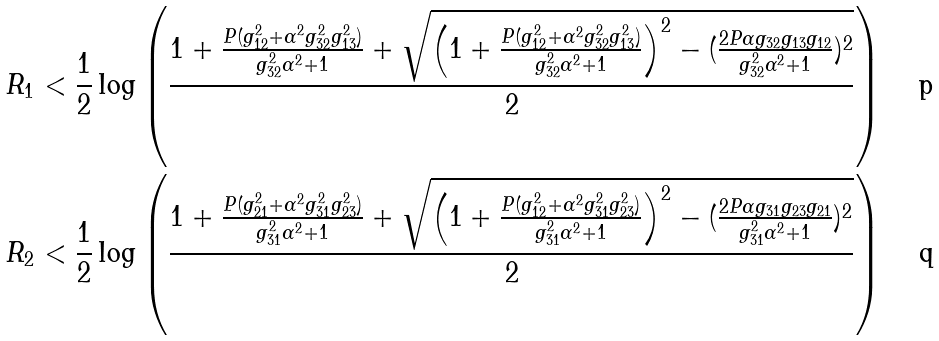<formula> <loc_0><loc_0><loc_500><loc_500>R _ { 1 } & < \frac { 1 } { 2 } \log \left ( \frac { 1 + \frac { P ( g _ { 1 2 } ^ { 2 } + \alpha ^ { 2 } g _ { 3 2 } ^ { 2 } g _ { 1 3 } ^ { 2 } ) } { g _ { 3 2 } ^ { 2 } \alpha ^ { 2 } + 1 } + \sqrt { \left ( 1 + \frac { P ( g _ { 1 2 } ^ { 2 } + \alpha ^ { 2 } g _ { 3 2 } ^ { 2 } g _ { 1 3 } ^ { 2 } ) } { g _ { 3 2 } ^ { 2 } \alpha ^ { 2 } + 1 } \right ) ^ { 2 } - ( \frac { 2 P \alpha g _ { 3 2 } g _ { 1 3 } g _ { 1 2 } } { g _ { 3 2 } ^ { 2 } \alpha ^ { 2 } + 1 } ) ^ { 2 } } } { 2 } \right ) \\ R _ { 2 } & < \frac { 1 } { 2 } \log \left ( \frac { 1 + \frac { P ( g _ { 2 1 } ^ { 2 } + \alpha ^ { 2 } g _ { 3 1 } ^ { 2 } g _ { 2 3 } ^ { 2 } ) } { g _ { 3 1 } ^ { 2 } \alpha ^ { 2 } + 1 } + \sqrt { \left ( 1 + \frac { P ( g _ { 1 2 } ^ { 2 } + \alpha ^ { 2 } g _ { 3 1 } ^ { 2 } g _ { 2 3 } ^ { 2 } ) } { g _ { 3 1 } ^ { 2 } \alpha ^ { 2 } + 1 } \right ) ^ { 2 } - ( \frac { 2 P \alpha g _ { 3 1 } g _ { 2 3 } g _ { 2 1 } } { g _ { 3 1 } ^ { 2 } \alpha ^ { 2 } + 1 } ) ^ { 2 } } } { 2 } \right )</formula> 